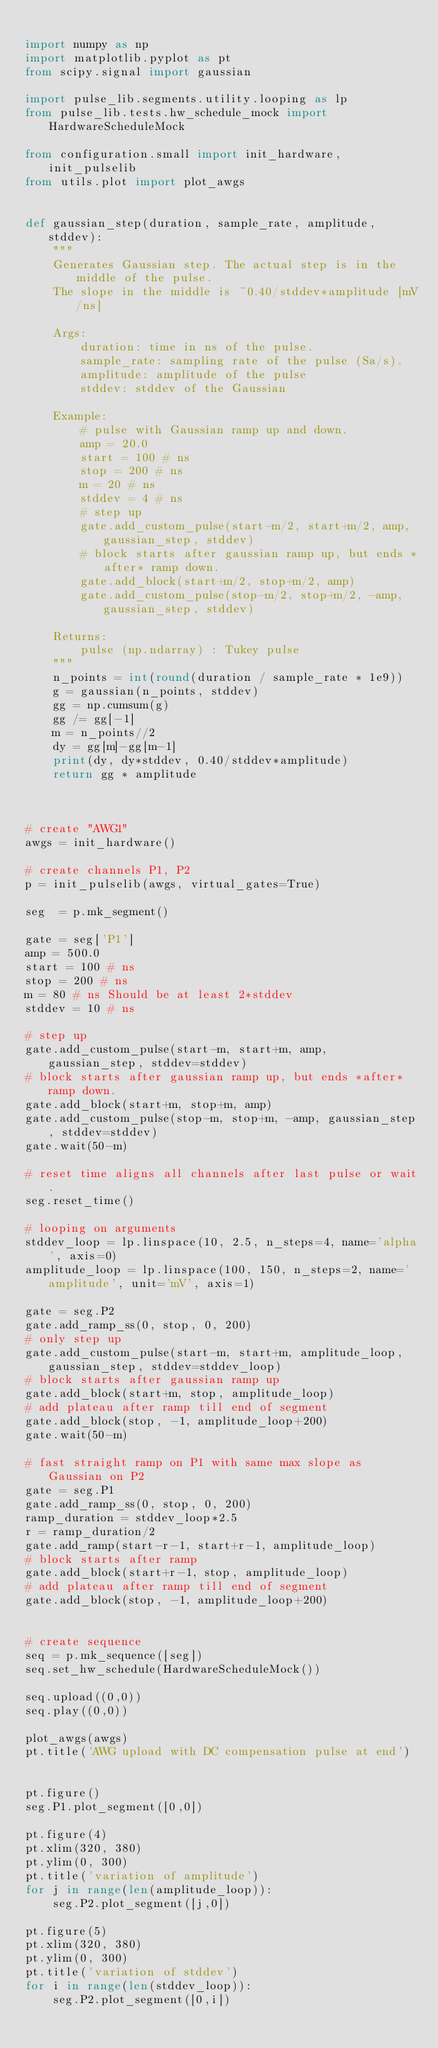Convert code to text. <code><loc_0><loc_0><loc_500><loc_500><_Python_>
import numpy as np
import matplotlib.pyplot as pt
from scipy.signal import gaussian

import pulse_lib.segments.utility.looping as lp
from pulse_lib.tests.hw_schedule_mock import HardwareScheduleMock

from configuration.small import init_hardware, init_pulselib
from utils.plot import plot_awgs


def gaussian_step(duration, sample_rate, amplitude, stddev):
    """
    Generates Gaussian step. The actual step is in the middle of the pulse.
    The slope in the middle is ~0.40/stddev*amplitude [mV/ns]

    Args:
        duration: time in ns of the pulse.
        sample_rate: sampling rate of the pulse (Sa/s).
        amplitude: amplitude of the pulse
        stddev: stddev of the Gaussian

    Example:
        # pulse with Gaussian ramp up and down.
        amp = 20.0
        start = 100 # ns
        stop = 200 # ns
        m = 20 # ns
        stddev = 4 # ns
        # step up
        gate.add_custom_pulse(start-m/2, start+m/2, amp, gaussian_step, stddev)
        # block starts after gaussian ramp up, but ends *after* ramp down.
        gate.add_block(start+m/2, stop+m/2, amp)
        gate.add_custom_pulse(stop-m/2, stop+m/2, -amp, gaussian_step, stddev)

    Returns:
        pulse (np.ndarray) : Tukey pulse
    """
    n_points = int(round(duration / sample_rate * 1e9))
    g = gaussian(n_points, stddev)
    gg = np.cumsum(g)
    gg /= gg[-1]
    m = n_points//2
    dy = gg[m]-gg[m-1]
    print(dy, dy*stddev, 0.40/stddev*amplitude)
    return gg * amplitude



# create "AWG1"
awgs = init_hardware()

# create channels P1, P2
p = init_pulselib(awgs, virtual_gates=True)

seg  = p.mk_segment()

gate = seg['P1']
amp = 500.0
start = 100 # ns
stop = 200 # ns
m = 80 # ns Should be at least 2*stddev
stddev = 10 # ns

# step up
gate.add_custom_pulse(start-m, start+m, amp, gaussian_step, stddev=stddev)
# block starts after gaussian ramp up, but ends *after* ramp down.
gate.add_block(start+m, stop+m, amp)
gate.add_custom_pulse(stop-m, stop+m, -amp, gaussian_step, stddev=stddev)
gate.wait(50-m)

# reset time aligns all channels after last pulse or wait.
seg.reset_time()

# looping on arguments
stddev_loop = lp.linspace(10, 2.5, n_steps=4, name='alpha', axis=0)
amplitude_loop = lp.linspace(100, 150, n_steps=2, name='amplitude', unit='mV', axis=1)

gate = seg.P2
gate.add_ramp_ss(0, stop, 0, 200)
# only step up
gate.add_custom_pulse(start-m, start+m, amplitude_loop, gaussian_step, stddev=stddev_loop)
# block starts after gaussian ramp up
gate.add_block(start+m, stop, amplitude_loop)
# add plateau after ramp till end of segment
gate.add_block(stop, -1, amplitude_loop+200)
gate.wait(50-m)

# fast straight ramp on P1 with same max slope as Gaussian on P2
gate = seg.P1
gate.add_ramp_ss(0, stop, 0, 200)
ramp_duration = stddev_loop*2.5
r = ramp_duration/2
gate.add_ramp(start-r-1, start+r-1, amplitude_loop)
# block starts after ramp
gate.add_block(start+r-1, stop, amplitude_loop)
# add plateau after ramp till end of segment
gate.add_block(stop, -1, amplitude_loop+200)


# create sequence
seq = p.mk_sequence([seg])
seq.set_hw_schedule(HardwareScheduleMock())

seq.upload((0,0))
seq.play((0,0))

plot_awgs(awgs)
pt.title('AWG upload with DC compensation pulse at end')


pt.figure()
seg.P1.plot_segment([0,0])

pt.figure(4)
pt.xlim(320, 380)
pt.ylim(0, 300)
pt.title('variation of amplitude')
for j in range(len(amplitude_loop)):
    seg.P2.plot_segment([j,0])

pt.figure(5)
pt.xlim(320, 380)
pt.ylim(0, 300)
pt.title('variation of stddev')
for i in range(len(stddev_loop)):
    seg.P2.plot_segment([0,i])
</code> 